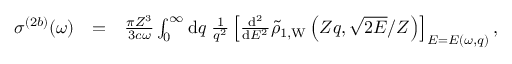<formula> <loc_0><loc_0><loc_500><loc_500>\begin{array} { r l r } { \sigma ^ { ( 2 b ) } ( \omega ) } & { = } & { \frac { \pi Z ^ { 3 } } { 3 c \omega } \int _ { 0 } ^ { \infty } { d } q \, \frac { 1 } { q ^ { 2 } } \left [ \frac { { d } ^ { 2 } } { { d } E ^ { 2 } } \tilde { \rho } _ { 1 , W } \left ( Z q , \sqrt { 2 E } / Z \right ) \right ] _ { E = E ( \omega , q ) } , } \end{array}</formula> 